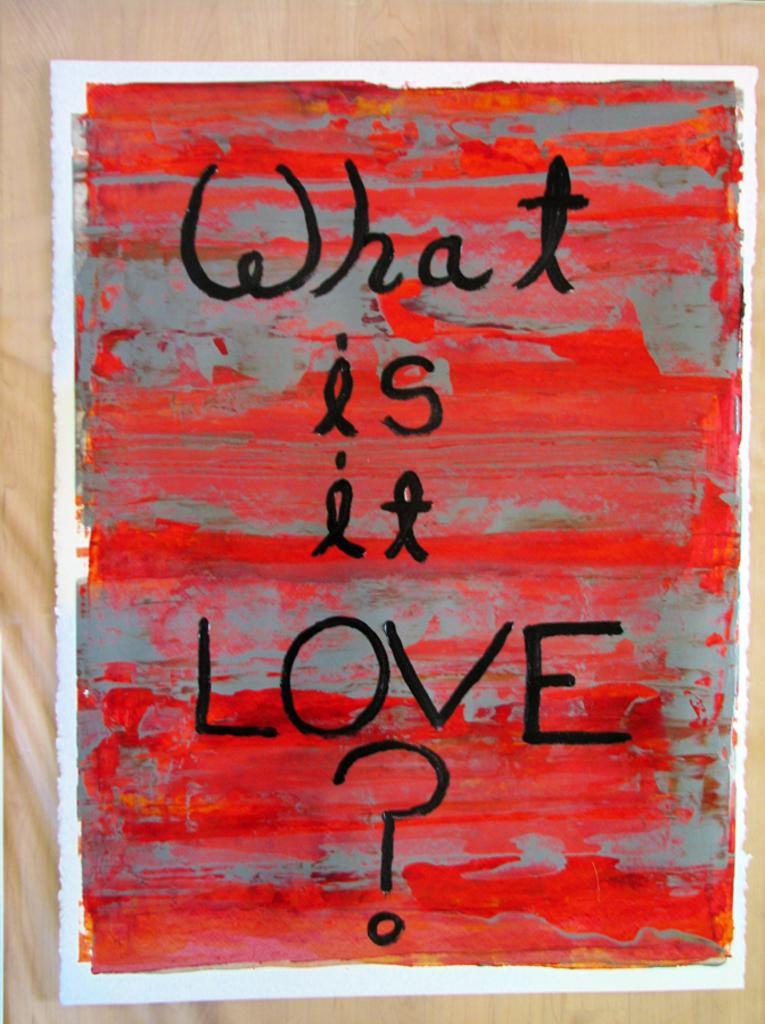<image>
Summarize the visual content of the image. A poster says What is it LOVE? on a red and gray background. 